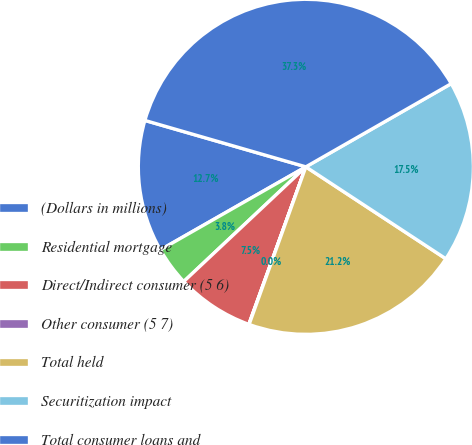Convert chart to OTSL. <chart><loc_0><loc_0><loc_500><loc_500><pie_chart><fcel>(Dollars in millions)<fcel>Residential mortgage<fcel>Direct/Indirect consumer (5 6)<fcel>Other consumer (5 7)<fcel>Total held<fcel>Securitization impact<fcel>Total consumer loans and<nl><fcel>12.72%<fcel>3.75%<fcel>7.47%<fcel>0.03%<fcel>21.25%<fcel>17.52%<fcel>37.26%<nl></chart> 